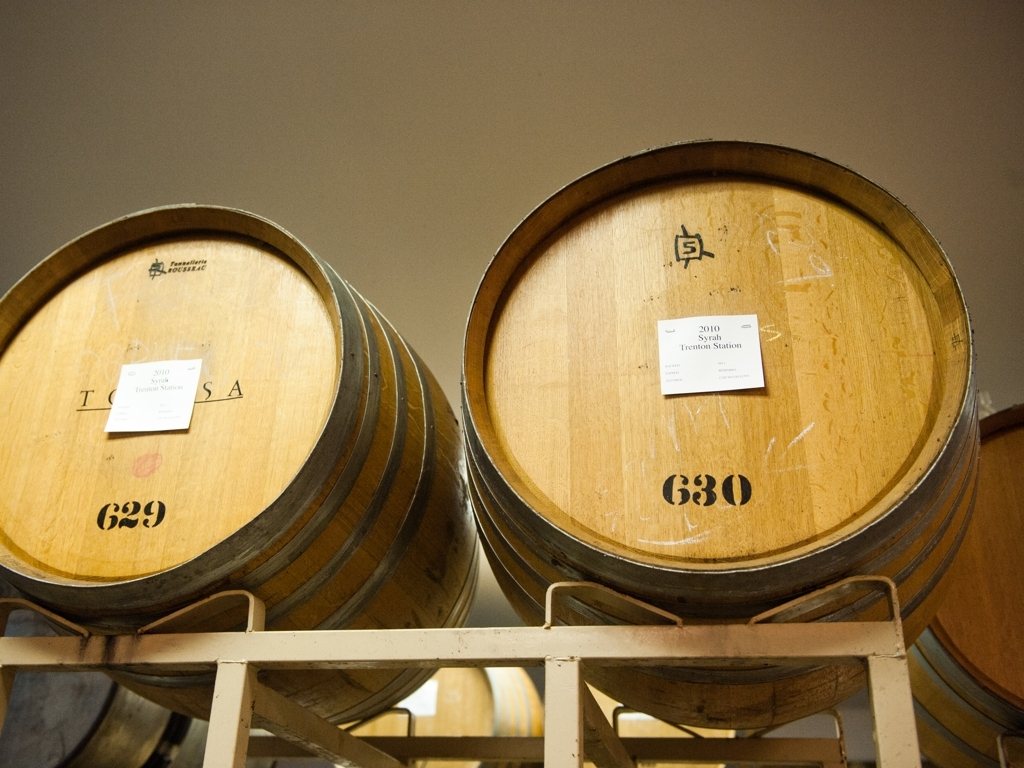What can you tell me about the items in this photograph? The image features two large wooden barrels commonly used in the aging process of wines and spirits. Each barrel has a label indicating that it is from a specific vineyard and vintage, suggesting that they may contain wine that is being aged for optimal taste and complexity. The barrels rest on shelving, likely situated in a cellar or storage room designed for wine aging. Could you guess the type of location this photo was taken in? Considering the barrels are labeled with vineyard names and vintages, and the environment appears controlled and indoors, it is probable that the photo was taken in a wine cellar or a storage area within a winery. These are the typical locations where barrels like these would be kept for the aging process. 